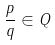Convert formula to latex. <formula><loc_0><loc_0><loc_500><loc_500>\frac { p } { q } \in Q</formula> 